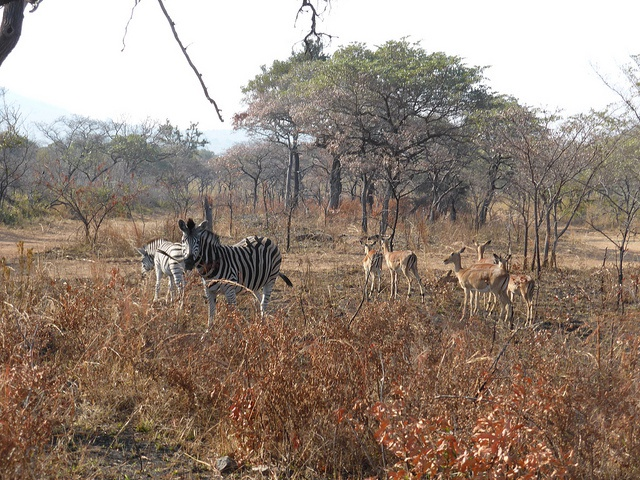Describe the objects in this image and their specific colors. I can see zebra in black and gray tones and zebra in black, gray, darkgray, and ivory tones in this image. 